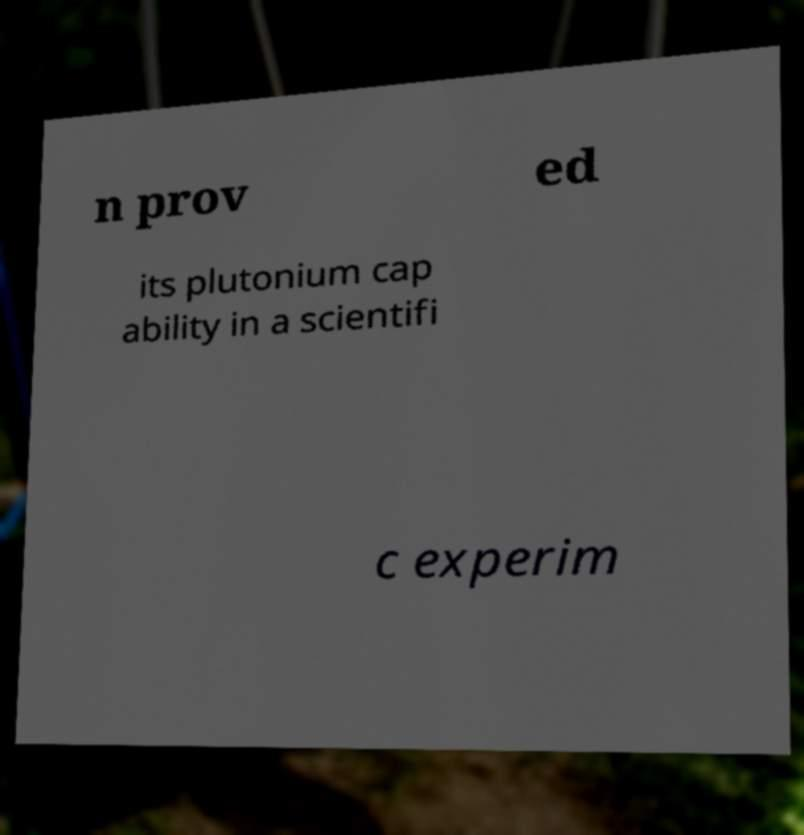Can you read and provide the text displayed in the image?This photo seems to have some interesting text. Can you extract and type it out for me? n prov ed its plutonium cap ability in a scientifi c experim 